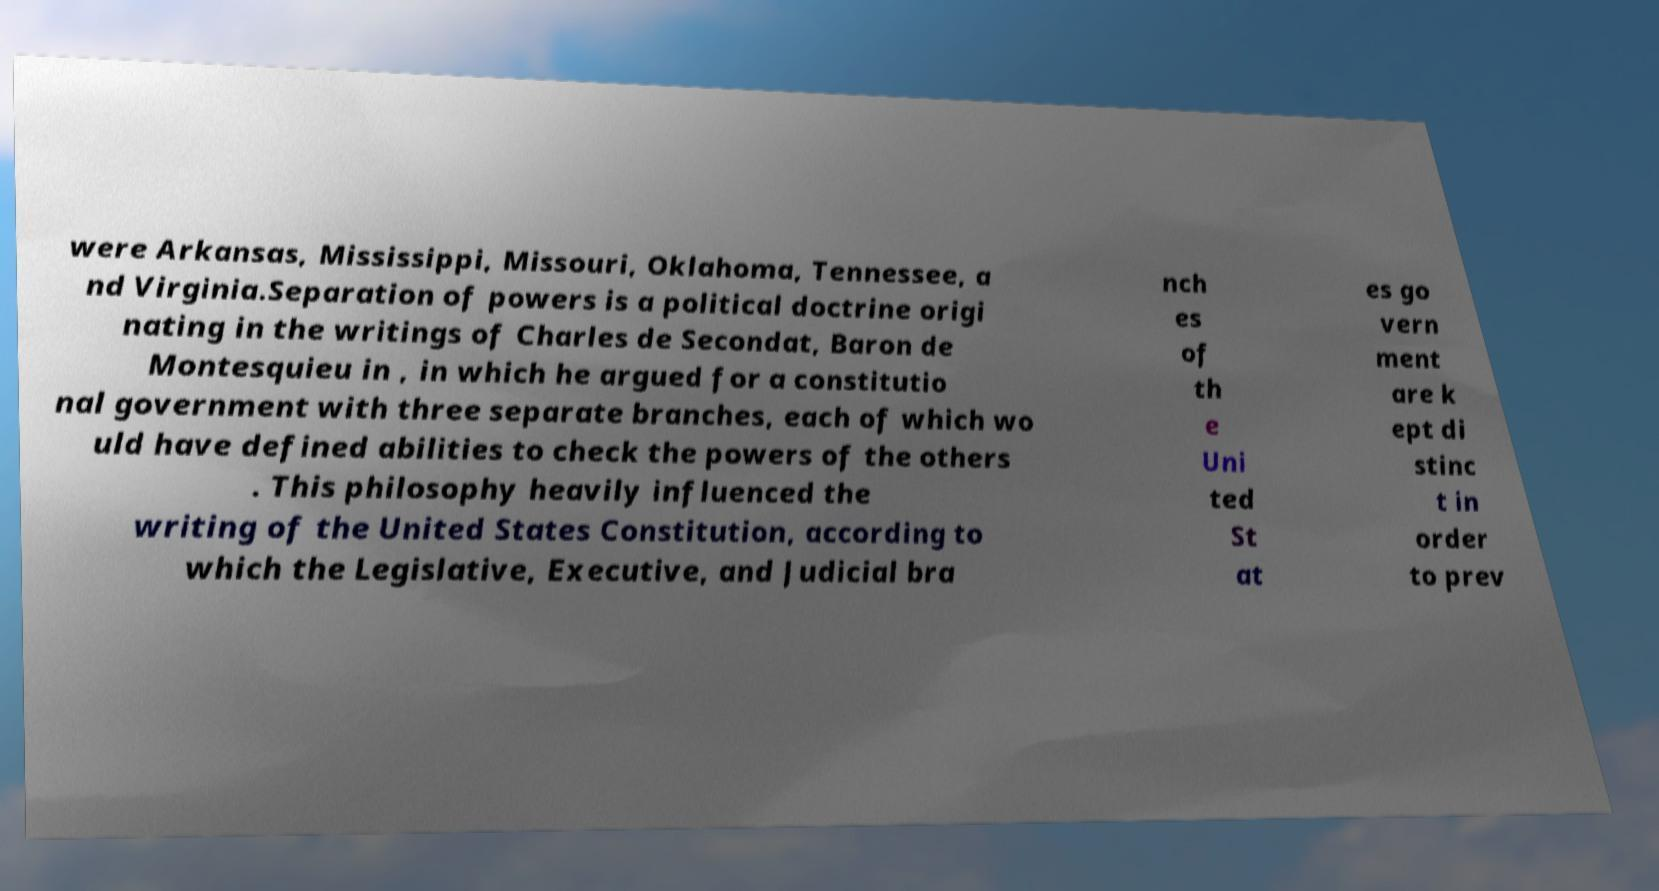Please read and relay the text visible in this image. What does it say? were Arkansas, Mississippi, Missouri, Oklahoma, Tennessee, a nd Virginia.Separation of powers is a political doctrine origi nating in the writings of Charles de Secondat, Baron de Montesquieu in , in which he argued for a constitutio nal government with three separate branches, each of which wo uld have defined abilities to check the powers of the others . This philosophy heavily influenced the writing of the United States Constitution, according to which the Legislative, Executive, and Judicial bra nch es of th e Uni ted St at es go vern ment are k ept di stinc t in order to prev 